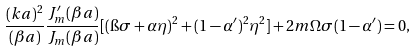<formula> <loc_0><loc_0><loc_500><loc_500>\frac { ( k a ) ^ { 2 } } { ( \beta a ) } \frac { J ^ { \prime } _ { m } ( \beta a ) } { J _ { m } ( \beta a ) } [ ( \i \sigma + \alpha \eta ) ^ { 2 } + ( 1 - \alpha ^ { \prime } ) ^ { 2 } \eta ^ { 2 } ] + 2 m \Omega \sigma ( 1 - \alpha ^ { \prime } ) = 0 ,</formula> 